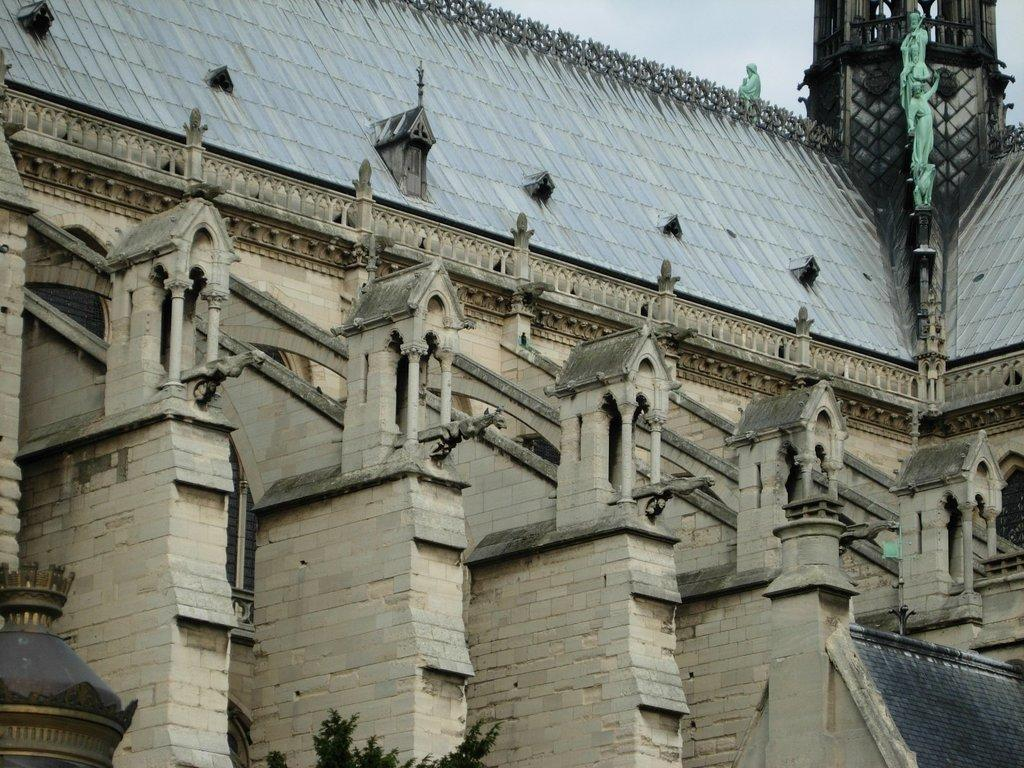What is the color of the building in the image? The building in the image is in ash and grey color. What can be seen to the right of the building? There are green color statues to the right of the building. What is the color of the sky visible in the background of the image? There is a blue sky visible in the background of the image. What role does the father play in the protest depicted in the image? There is no protest or father present in the image; it features a building with green statues and a blue sky in the background. 